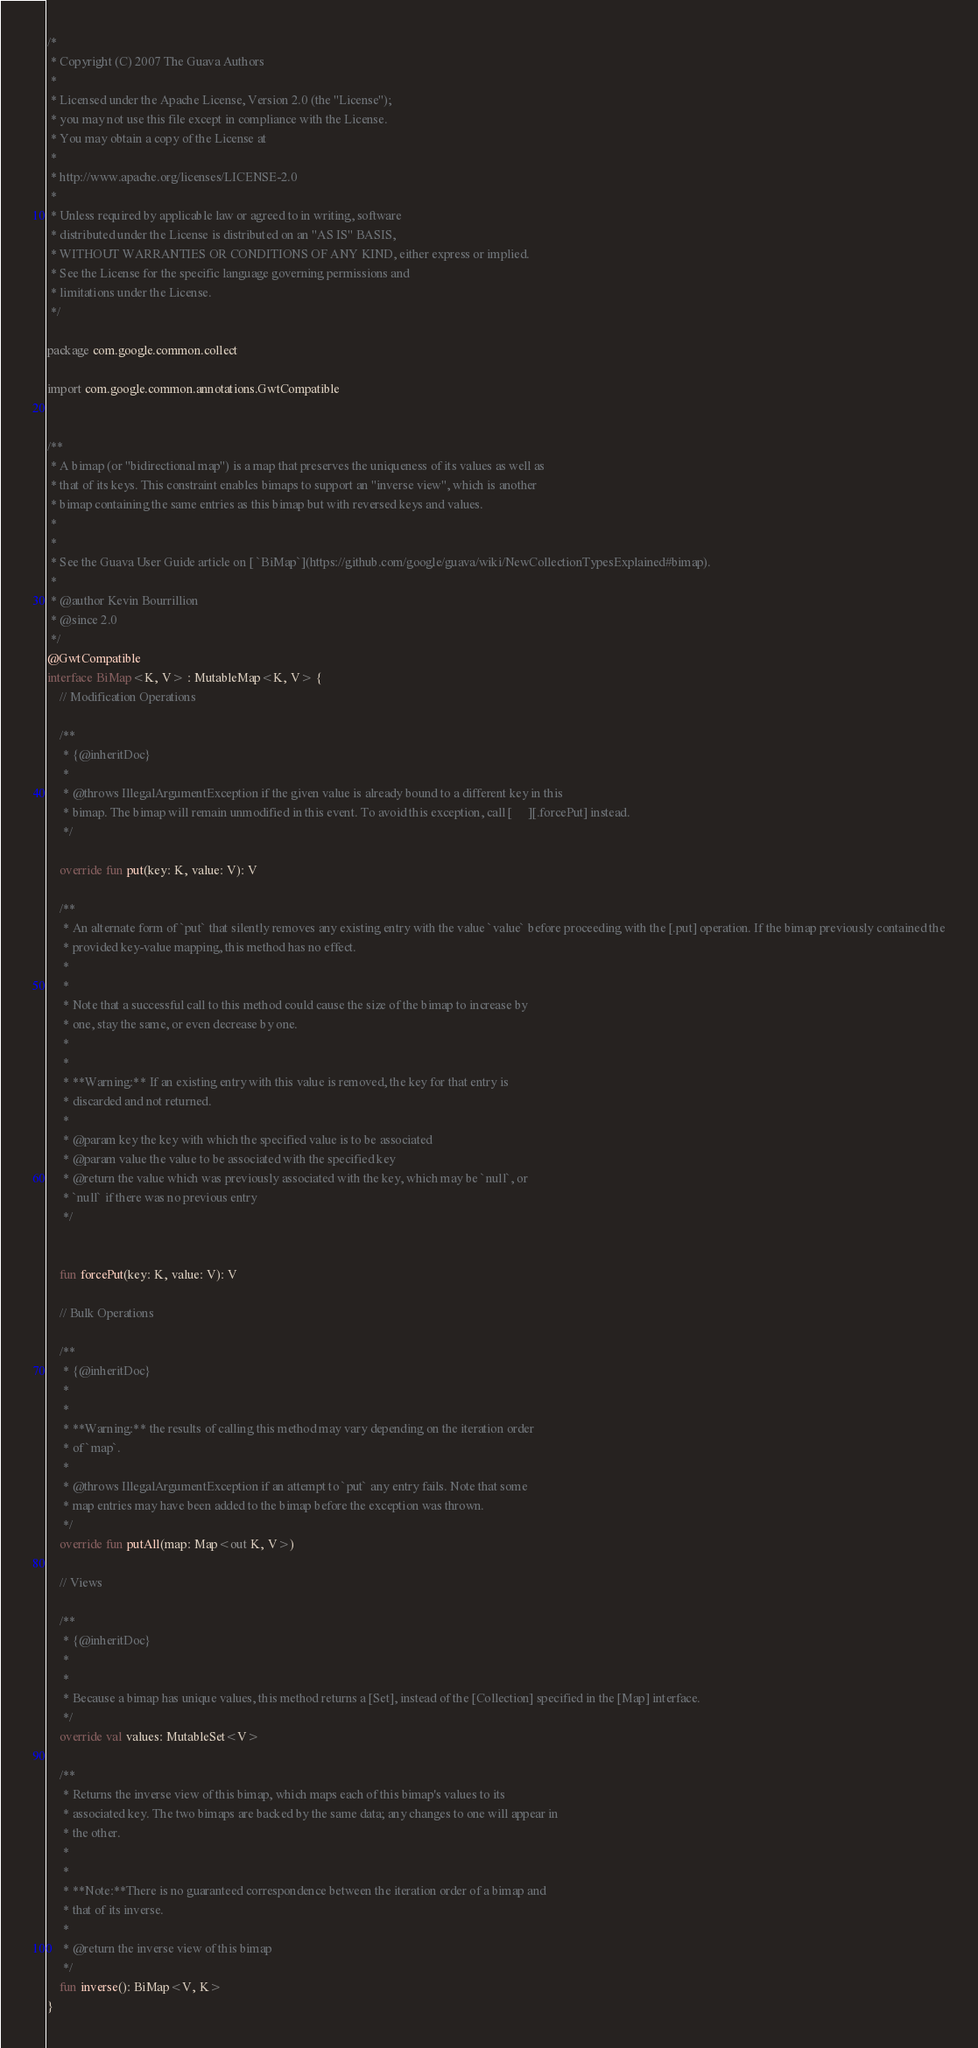<code> <loc_0><loc_0><loc_500><loc_500><_Kotlin_>/*
 * Copyright (C) 2007 The Guava Authors
 *
 * Licensed under the Apache License, Version 2.0 (the "License");
 * you may not use this file except in compliance with the License.
 * You may obtain a copy of the License at
 *
 * http://www.apache.org/licenses/LICENSE-2.0
 *
 * Unless required by applicable law or agreed to in writing, software
 * distributed under the License is distributed on an "AS IS" BASIS,
 * WITHOUT WARRANTIES OR CONDITIONS OF ANY KIND, either express or implied.
 * See the License for the specific language governing permissions and
 * limitations under the License.
 */

package com.google.common.collect

import com.google.common.annotations.GwtCompatible


/**
 * A bimap (or "bidirectional map") is a map that preserves the uniqueness of its values as well as
 * that of its keys. This constraint enables bimaps to support an "inverse view", which is another
 * bimap containing the same entries as this bimap but with reversed keys and values.
 *
 *
 * See the Guava User Guide article on [ `BiMap`](https://github.com/google/guava/wiki/NewCollectionTypesExplained#bimap).
 *
 * @author Kevin Bourrillion
 * @since 2.0
 */
@GwtCompatible
interface BiMap<K, V> : MutableMap<K, V> {
    // Modification Operations

    /**
     * {@inheritDoc}
     *
     * @throws IllegalArgumentException if the given value is already bound to a different key in this
     * bimap. The bimap will remain unmodified in this event. To avoid this exception, call [     ][.forcePut] instead.
     */

    override fun put(key: K, value: V): V

    /**
     * An alternate form of `put` that silently removes any existing entry with the value `value` before proceeding with the [.put] operation. If the bimap previously contained the
     * provided key-value mapping, this method has no effect.
     *
     *
     * Note that a successful call to this method could cause the size of the bimap to increase by
     * one, stay the same, or even decrease by one.
     *
     *
     * **Warning:** If an existing entry with this value is removed, the key for that entry is
     * discarded and not returned.
     *
     * @param key the key with which the specified value is to be associated
     * @param value the value to be associated with the specified key
     * @return the value which was previously associated with the key, which may be `null`, or
     * `null` if there was no previous entry
     */


    fun forcePut(key: K, value: V): V

    // Bulk Operations

    /**
     * {@inheritDoc}
     *
     *
     * **Warning:** the results of calling this method may vary depending on the iteration order
     * of `map`.
     *
     * @throws IllegalArgumentException if an attempt to `put` any entry fails. Note that some
     * map entries may have been added to the bimap before the exception was thrown.
     */
    override fun putAll(map: Map<out K, V>)

    // Views

    /**
     * {@inheritDoc}
     *
     *
     * Because a bimap has unique values, this method returns a [Set], instead of the [Collection] specified in the [Map] interface.
     */
    override val values: MutableSet<V>

    /**
     * Returns the inverse view of this bimap, which maps each of this bimap's values to its
     * associated key. The two bimaps are backed by the same data; any changes to one will appear in
     * the other.
     *
     *
     * **Note:**There is no guaranteed correspondence between the iteration order of a bimap and
     * that of its inverse.
     *
     * @return the inverse view of this bimap
     */
    fun inverse(): BiMap<V, K>
}
</code> 